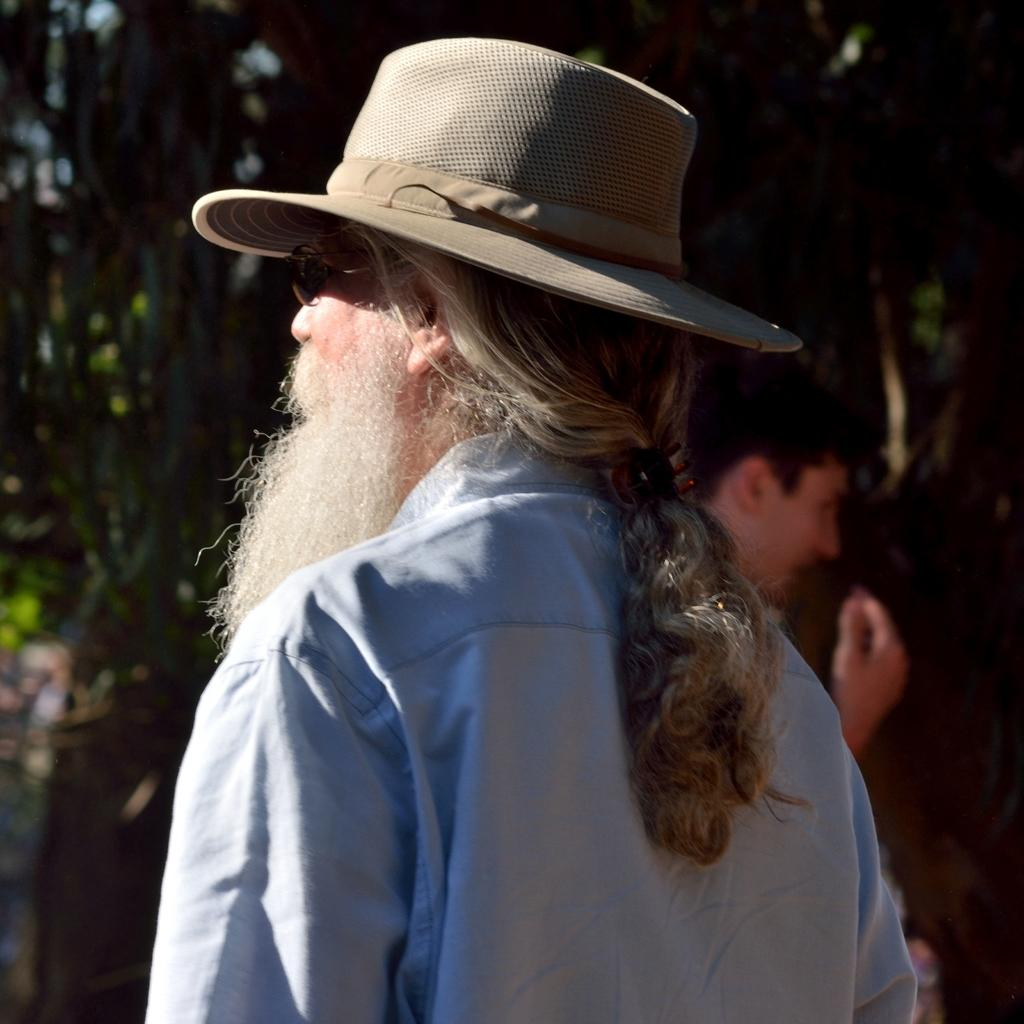How many people are in the image? There are two persons in the image. What are the two persons doing in the image? The two persons are standing. Can you describe the background of the image? The background of the image is blurred. What type of pig is visible in the image? There is no pig present in the image. What kind of apparel are the persons wearing in the image? The provided facts do not mention any specific apparel worn by the persons in the image. How many birds can be seen flying in the image? There are no birds visible in the image. 